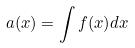Convert formula to latex. <formula><loc_0><loc_0><loc_500><loc_500>a ( x ) = \int f ( x ) d x</formula> 